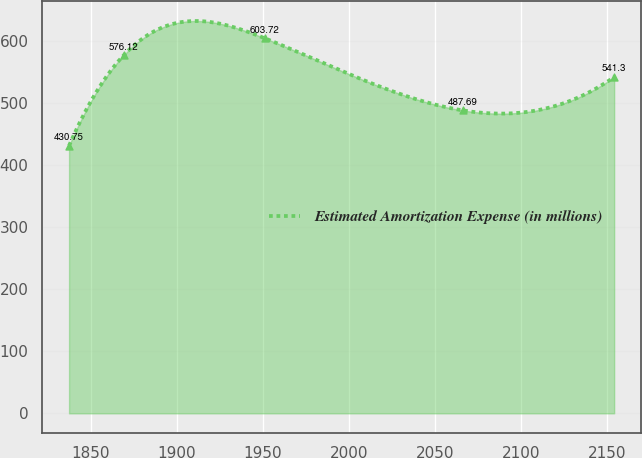<chart> <loc_0><loc_0><loc_500><loc_500><line_chart><ecel><fcel>Estimated Amortization Expense (in millions)<nl><fcel>1837.37<fcel>430.75<nl><fcel>1869.03<fcel>576.12<nl><fcel>1951.1<fcel>603.72<nl><fcel>2065.97<fcel>487.69<nl><fcel>2153.98<fcel>541.3<nl></chart> 